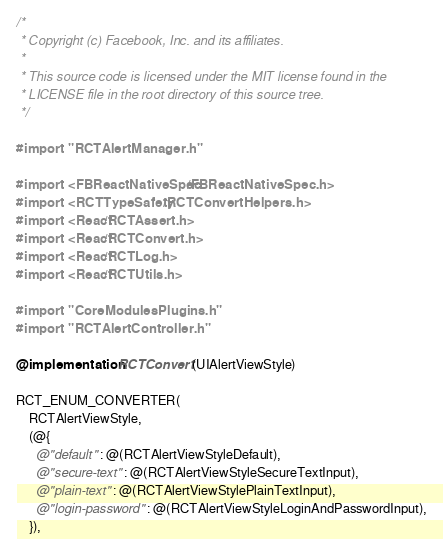<code> <loc_0><loc_0><loc_500><loc_500><_ObjectiveC_>/*
 * Copyright (c) Facebook, Inc. and its affiliates.
 *
 * This source code is licensed under the MIT license found in the
 * LICENSE file in the root directory of this source tree.
 */

#import "RCTAlertManager.h"

#import <FBReactNativeSpec/FBReactNativeSpec.h>
#import <RCTTypeSafety/RCTConvertHelpers.h>
#import <React/RCTAssert.h>
#import <React/RCTConvert.h>
#import <React/RCTLog.h>
#import <React/RCTUtils.h>

#import "CoreModulesPlugins.h"
#import "RCTAlertController.h"

@implementation RCTConvert (UIAlertViewStyle)

RCT_ENUM_CONVERTER(
    RCTAlertViewStyle,
    (@{
      @"default" : @(RCTAlertViewStyleDefault),
      @"secure-text" : @(RCTAlertViewStyleSecureTextInput),
      @"plain-text" : @(RCTAlertViewStylePlainTextInput),
      @"login-password" : @(RCTAlertViewStyleLoginAndPasswordInput),
    }),</code> 